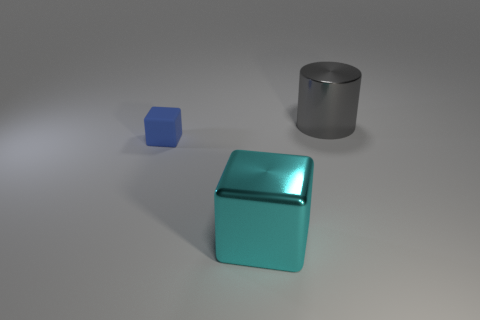What number of other objects are the same material as the tiny blue thing?
Your answer should be compact. 0. What number of shiny objects are either small blue cubes or small brown balls?
Offer a terse response. 0. There is a thing on the left side of the metallic cube; does it have the same shape as the large cyan metal thing?
Offer a very short reply. Yes. Is the number of small blue blocks that are behind the cyan metal thing greater than the number of balls?
Provide a succinct answer. Yes. How many objects are both in front of the gray shiny object and behind the cyan object?
Your answer should be compact. 1. What is the color of the large metal object that is to the left of the large object on the right side of the cyan metal object?
Give a very brief answer. Cyan. What number of rubber things have the same color as the big block?
Provide a short and direct response. 0. Does the metallic cube have the same color as the large thing that is behind the matte object?
Your answer should be very brief. No. Is the number of blue things less than the number of big red metal spheres?
Give a very brief answer. No. Is the number of metallic objects that are behind the large gray cylinder greater than the number of blocks that are in front of the blue cube?
Offer a terse response. No. 